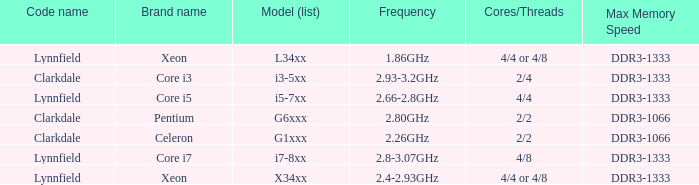List the number of cores for ddr3-1333 with frequencies between 2.66-2.8ghz. 4/4. 